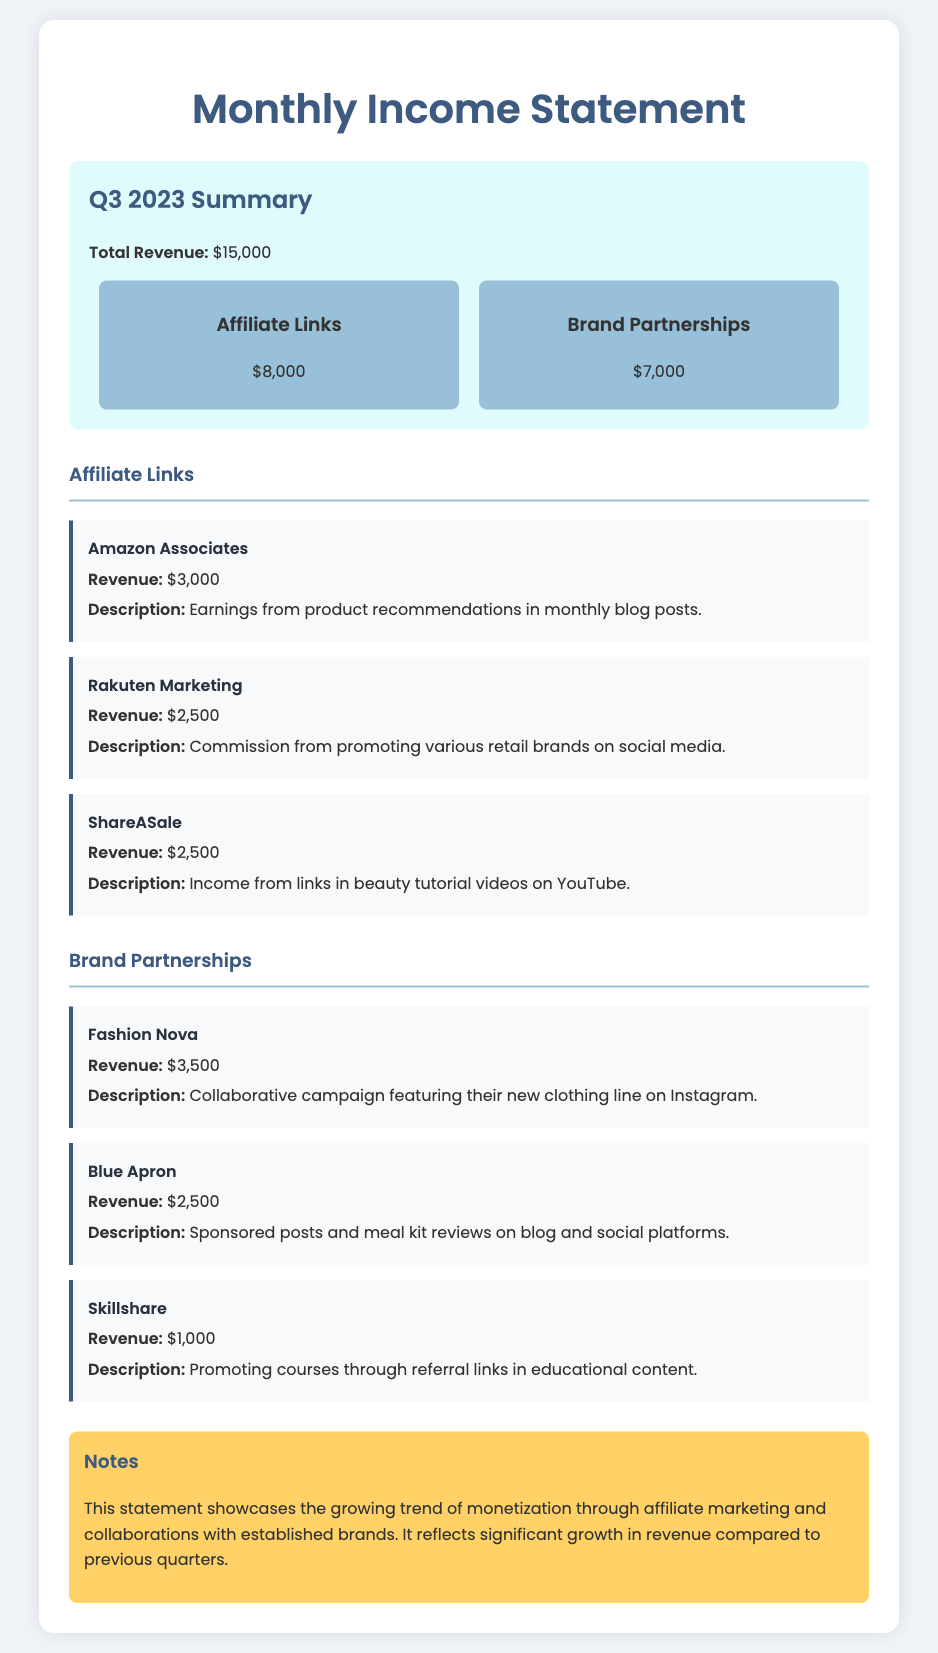What is the total revenue? The total revenue is displayed as the sum total from all sources in the document, which is $8,000 + $7,000.
Answer: $15,000 How much revenue did affiliate links generate? The revenue generated from affiliate links is specified in the income statement as $8,000.
Answer: $8,000 What was the revenue from Fashion Nova? The document lists the revenue from Fashion Nova under brand partnerships as $3,500.
Answer: $3,500 Which affiliate program generated $3,000? The document specifies that Amazon Associates generated $3,000, including a brief description of this income source.
Answer: Amazon Associates What is the total revenue from Brand Partnerships? The total revenue from brand partnerships is derived from the sums of all specific brand partnerships listed, which equals $7,000.
Answer: $7,000 How many income sources are detailed in the affiliate links section? The document outlines three specific income sources under affiliate links.
Answer: Three What is the revenue from Skillshare? The Skillshare revenue is provided in the document as $1,000.
Answer: $1,000 What trends can be inferred from the notes section? The notes highlight a growing trend in monetization through affiliate marketing and collaborations, indicating an uptick in revenue compared to prior quarters.
Answer: Growing trend Which brand partnership had the lowest revenue? The document mentions Skillshare as the brand partnership that had the lowest revenue at $1,000.
Answer: Skillshare 